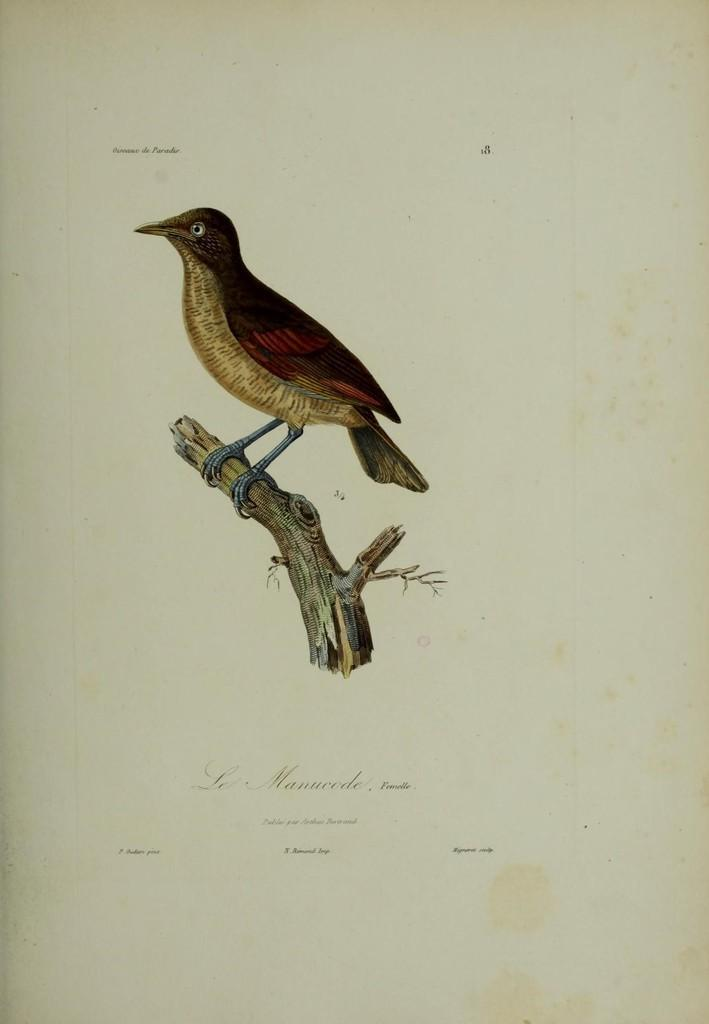What is depicted in the drawing that is visible in the image? There is a drawing of a bird and a drawing of a wood in the image. What is the medium on which the drawings are made? Both drawings are on a paper. How much money is the bird holding in the drawing? The bird in the drawing is not holding any money, as it is a drawing and not a real bird. What type of worm can be seen in the drawing of the wood? There is no worm depicted in the drawing of the wood; it only shows a wood. 